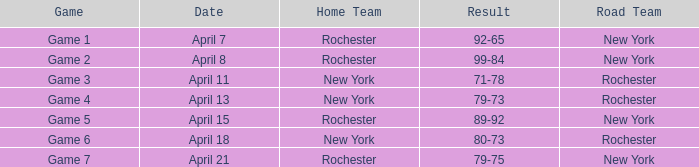Which date includes a game of game 3? April 11. 